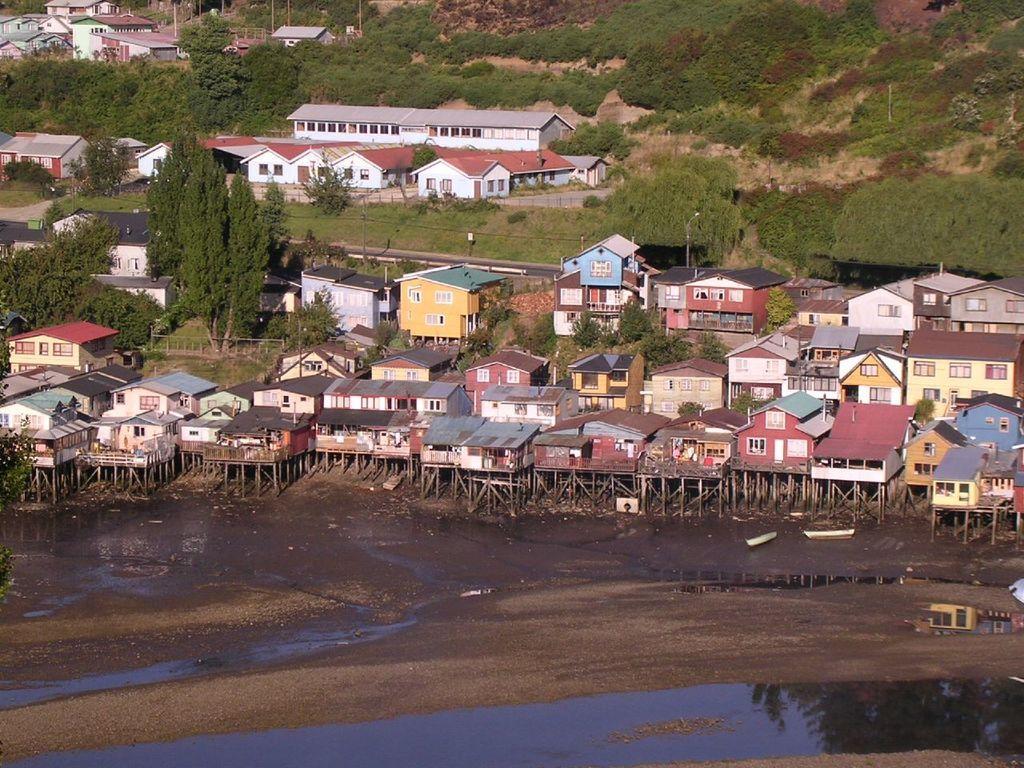Could you give a brief overview of what you see in this image? In this image I can see buildings, trees, water and poles. Here I can see boats and some other objects on the ground. 